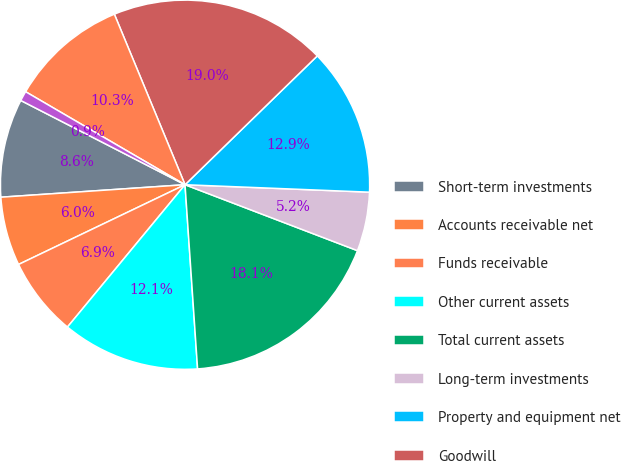Convert chart to OTSL. <chart><loc_0><loc_0><loc_500><loc_500><pie_chart><fcel>Short-term investments<fcel>Accounts receivable net<fcel>Funds receivable<fcel>Other current assets<fcel>Total current assets<fcel>Long-term investments<fcel>Property and equipment net<fcel>Goodwill<fcel>Intangible assets net<fcel>Other assets<nl><fcel>8.62%<fcel>6.03%<fcel>6.9%<fcel>12.07%<fcel>18.1%<fcel>5.17%<fcel>12.93%<fcel>18.96%<fcel>10.34%<fcel>0.86%<nl></chart> 